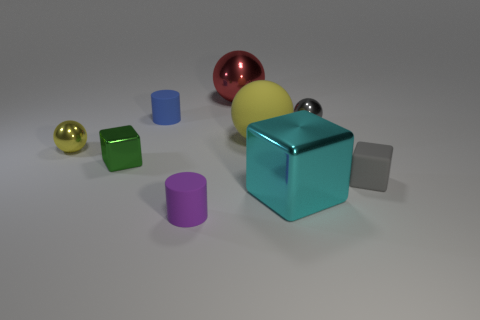Do the shiny block that is left of the big cube and the yellow object left of the tiny purple rubber object have the same size?
Offer a terse response. Yes. What number of objects are cylinders right of the blue rubber object or large brown metallic spheres?
Provide a short and direct response. 1. Are there fewer green objects than big green metal objects?
Your answer should be very brief. No. There is a yellow thing left of the tiny cylinder that is in front of the metallic block that is in front of the tiny gray matte block; what shape is it?
Give a very brief answer. Sphere. Are there any tiny purple cylinders?
Make the answer very short. Yes. There is a purple cylinder; does it have the same size as the rubber cylinder that is behind the rubber sphere?
Your answer should be very brief. Yes. There is a large metallic thing that is to the left of the cyan shiny cube; is there a rubber thing in front of it?
Make the answer very short. Yes. There is a small object that is behind the large rubber ball and in front of the tiny blue matte cylinder; what material is it?
Offer a terse response. Metal. The cylinder behind the tiny ball that is on the left side of the big metallic sphere on the right side of the purple object is what color?
Provide a short and direct response. Blue. There is a matte ball that is the same size as the cyan cube; what is its color?
Ensure brevity in your answer.  Yellow. 